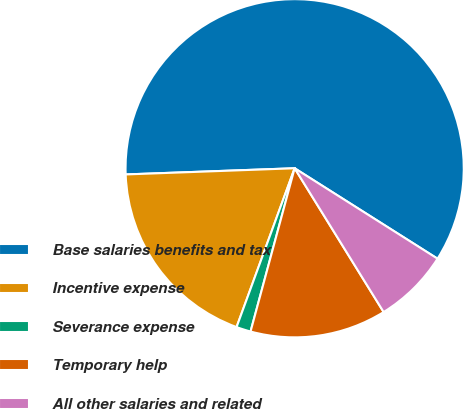<chart> <loc_0><loc_0><loc_500><loc_500><pie_chart><fcel>Base salaries benefits and tax<fcel>Incentive expense<fcel>Severance expense<fcel>Temporary help<fcel>All other salaries and related<nl><fcel>59.57%<fcel>18.84%<fcel>1.38%<fcel>13.02%<fcel>7.2%<nl></chart> 